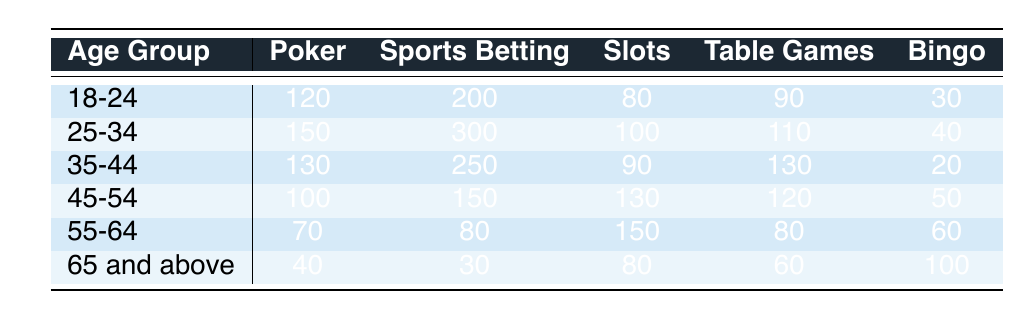What is the total number of gamblers aged 25-34 who prefer Sports Betting? According to the table, the number of gamblers aged 25-34 who prefer Sports Betting is 300, as explicitly stated in the column under Sports Betting for that age group.
Answer: 300 Which age group has the highest preference for Slots? By looking at the Slots column, the highest number of gamblers is from the 55-64 age group with 150. Comparing all age group values in the Slots column, none exceed this number.
Answer: 55-64 What is the difference in the number of Poker players between the 35-44 age group and the 45-54 age group? The 35-44 age group has 130 Poker players, while the 45-54 age group has 100. The difference is calculated as 130 - 100 = 30.
Answer: 30 Is the number of Bingo players in the 65 and above age group greater than the number of Bingo players in the 18-24 age group? The number of Bingo players in the 65 and above age group is 100, while in the 18-24 age group it is 30. Since 100 is greater than 30, the statement is true.
Answer: Yes What is the average number of Sports Betting participants across all age groups? The number of Sports Betting participants in each age group is 200 (18-24), 300 (25-34), 250 (35-44), 150 (45-54), 80 (55-64), and 30 (65 and above). Summing these values gives 200 + 300 + 250 + 150 + 80 + 30 = 1010. There are 6 age groups, so the average is 1010 / 6 = 168.33, which we round down to 168.
Answer: 168 Which age group has the lowest preference for Table Games? Looking at the Table Games column, the lowest number of players is in the 65 and above age group with 60 players. All other age groups have more, making this the minimum.
Answer: 65 and above 